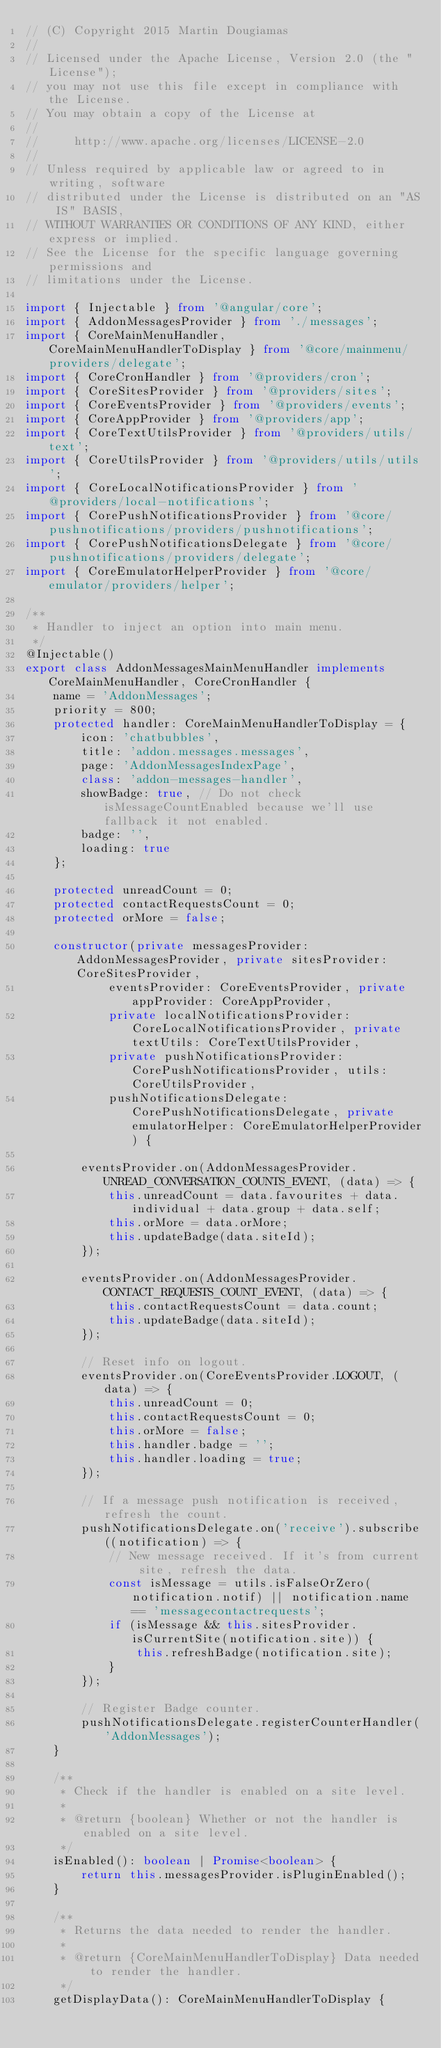Convert code to text. <code><loc_0><loc_0><loc_500><loc_500><_TypeScript_>// (C) Copyright 2015 Martin Dougiamas
//
// Licensed under the Apache License, Version 2.0 (the "License");
// you may not use this file except in compliance with the License.
// You may obtain a copy of the License at
//
//     http://www.apache.org/licenses/LICENSE-2.0
//
// Unless required by applicable law or agreed to in writing, software
// distributed under the License is distributed on an "AS IS" BASIS,
// WITHOUT WARRANTIES OR CONDITIONS OF ANY KIND, either express or implied.
// See the License for the specific language governing permissions and
// limitations under the License.

import { Injectable } from '@angular/core';
import { AddonMessagesProvider } from './messages';
import { CoreMainMenuHandler, CoreMainMenuHandlerToDisplay } from '@core/mainmenu/providers/delegate';
import { CoreCronHandler } from '@providers/cron';
import { CoreSitesProvider } from '@providers/sites';
import { CoreEventsProvider } from '@providers/events';
import { CoreAppProvider } from '@providers/app';
import { CoreTextUtilsProvider } from '@providers/utils/text';
import { CoreUtilsProvider } from '@providers/utils/utils';
import { CoreLocalNotificationsProvider } from '@providers/local-notifications';
import { CorePushNotificationsProvider } from '@core/pushnotifications/providers/pushnotifications';
import { CorePushNotificationsDelegate } from '@core/pushnotifications/providers/delegate';
import { CoreEmulatorHelperProvider } from '@core/emulator/providers/helper';

/**
 * Handler to inject an option into main menu.
 */
@Injectable()
export class AddonMessagesMainMenuHandler implements CoreMainMenuHandler, CoreCronHandler {
    name = 'AddonMessages';
    priority = 800;
    protected handler: CoreMainMenuHandlerToDisplay = {
        icon: 'chatbubbles',
        title: 'addon.messages.messages',
        page: 'AddonMessagesIndexPage',
        class: 'addon-messages-handler',
        showBadge: true, // Do not check isMessageCountEnabled because we'll use fallback it not enabled.
        badge: '',
        loading: true
    };

    protected unreadCount = 0;
    protected contactRequestsCount = 0;
    protected orMore = false;

    constructor(private messagesProvider: AddonMessagesProvider, private sitesProvider: CoreSitesProvider,
            eventsProvider: CoreEventsProvider, private appProvider: CoreAppProvider,
            private localNotificationsProvider: CoreLocalNotificationsProvider, private textUtils: CoreTextUtilsProvider,
            private pushNotificationsProvider: CorePushNotificationsProvider, utils: CoreUtilsProvider,
            pushNotificationsDelegate: CorePushNotificationsDelegate, private emulatorHelper: CoreEmulatorHelperProvider) {

        eventsProvider.on(AddonMessagesProvider.UNREAD_CONVERSATION_COUNTS_EVENT, (data) => {
            this.unreadCount = data.favourites + data.individual + data.group + data.self;
            this.orMore = data.orMore;
            this.updateBadge(data.siteId);
        });

        eventsProvider.on(AddonMessagesProvider.CONTACT_REQUESTS_COUNT_EVENT, (data) => {
            this.contactRequestsCount = data.count;
            this.updateBadge(data.siteId);
        });

        // Reset info on logout.
        eventsProvider.on(CoreEventsProvider.LOGOUT, (data) => {
            this.unreadCount = 0;
            this.contactRequestsCount = 0;
            this.orMore = false;
            this.handler.badge = '';
            this.handler.loading = true;
        });

        // If a message push notification is received, refresh the count.
        pushNotificationsDelegate.on('receive').subscribe((notification) => {
            // New message received. If it's from current site, refresh the data.
            const isMessage = utils.isFalseOrZero(notification.notif) || notification.name == 'messagecontactrequests';
            if (isMessage && this.sitesProvider.isCurrentSite(notification.site)) {
                this.refreshBadge(notification.site);
            }
        });

        // Register Badge counter.
        pushNotificationsDelegate.registerCounterHandler('AddonMessages');
    }

    /**
     * Check if the handler is enabled on a site level.
     *
     * @return {boolean} Whether or not the handler is enabled on a site level.
     */
    isEnabled(): boolean | Promise<boolean> {
        return this.messagesProvider.isPluginEnabled();
    }

    /**
     * Returns the data needed to render the handler.
     *
     * @return {CoreMainMenuHandlerToDisplay} Data needed to render the handler.
     */
    getDisplayData(): CoreMainMenuHandlerToDisplay {</code> 